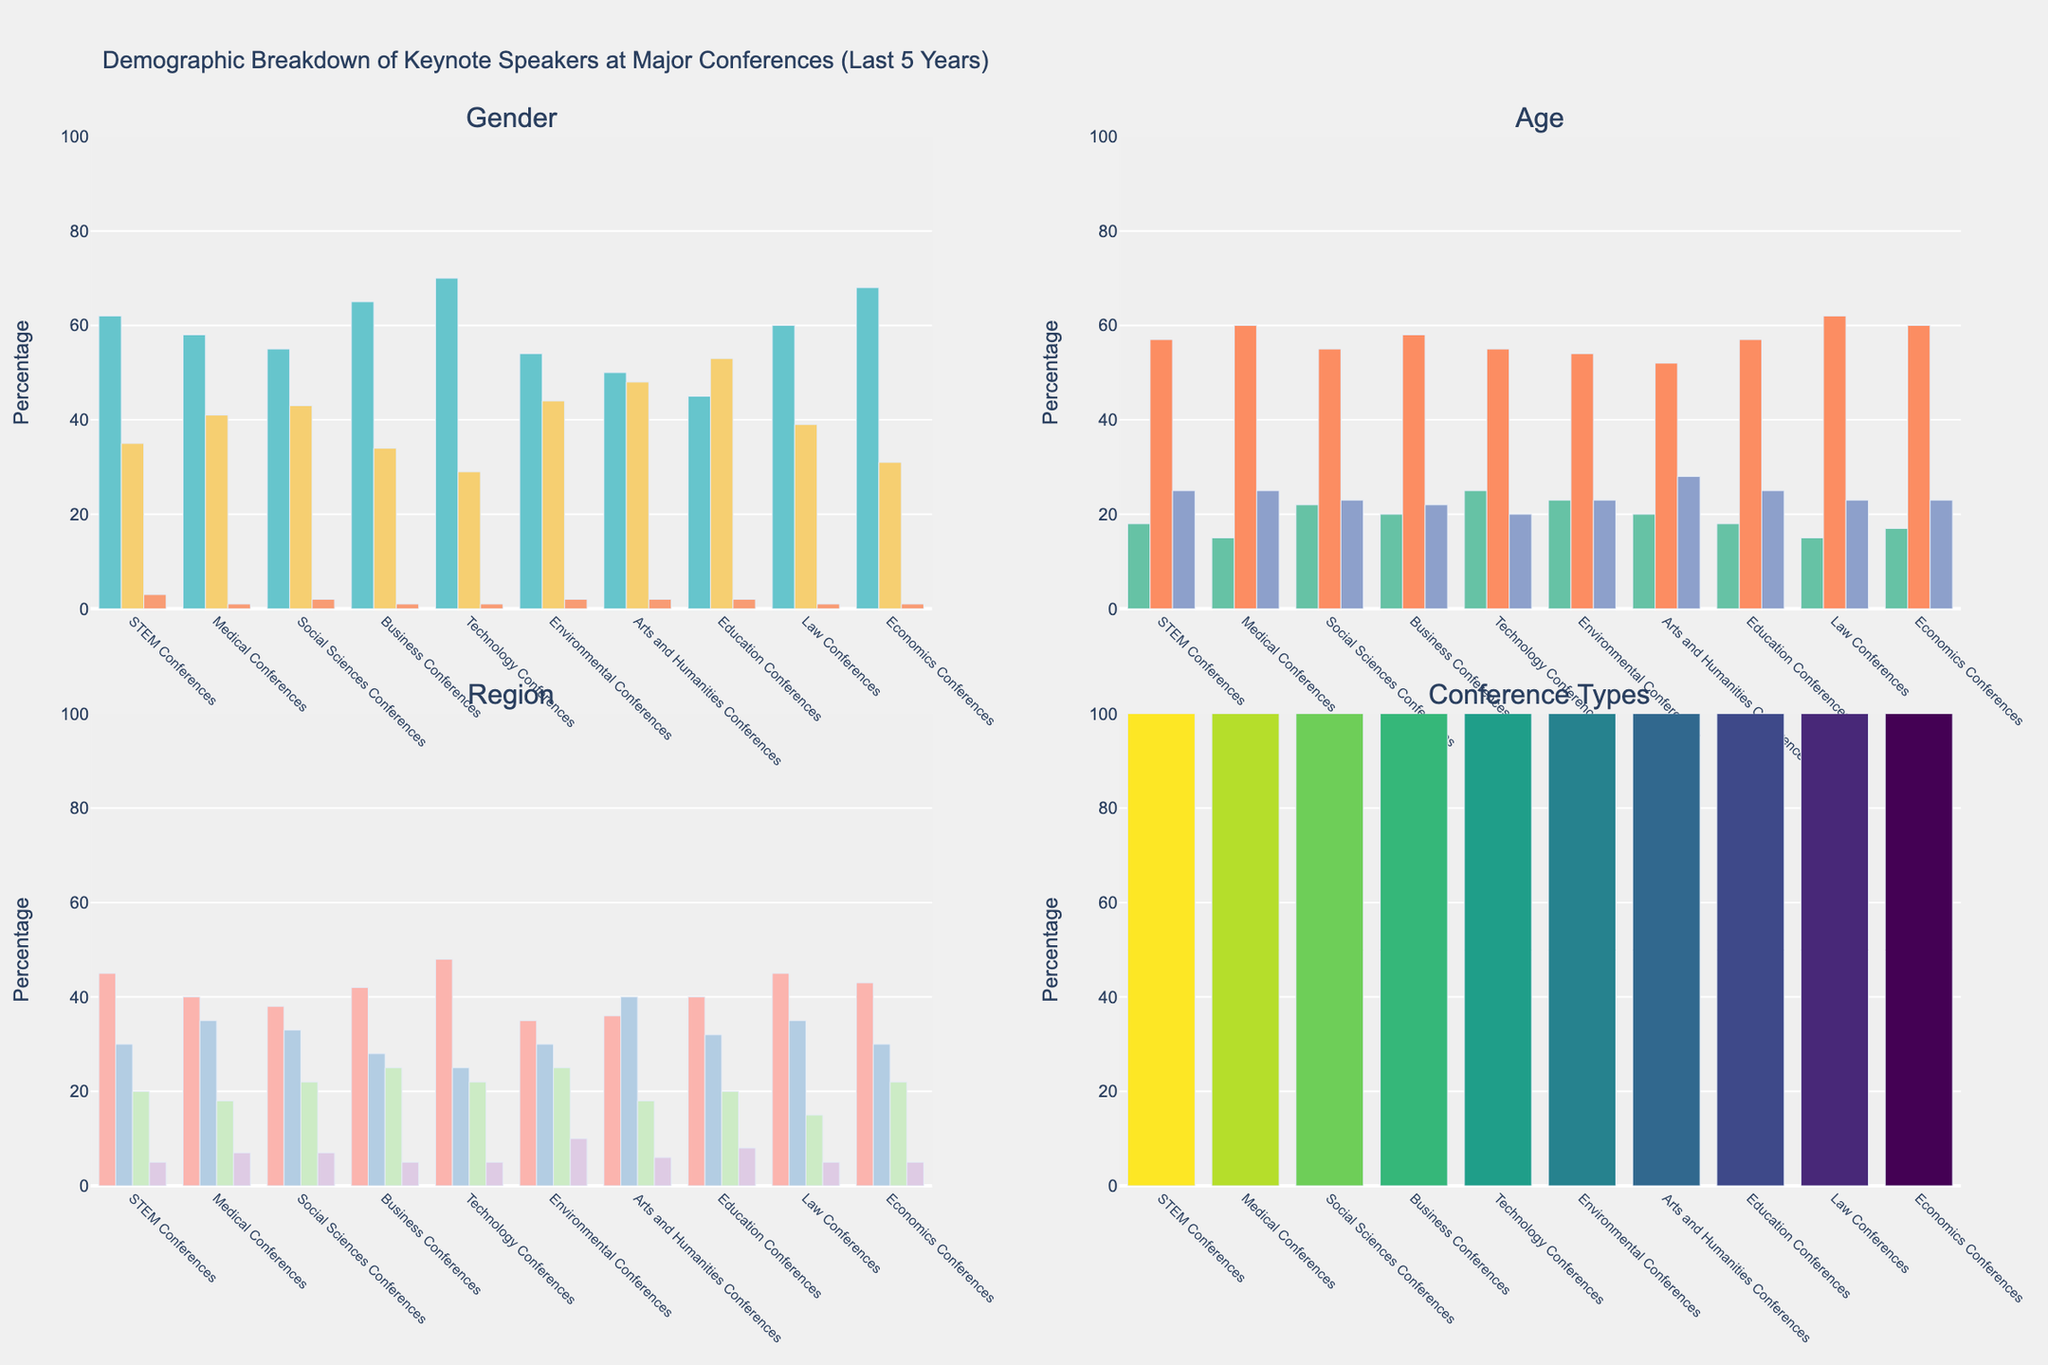What's the total number of male keynote speakers across all conference types? To find the total number of male keynote speakers, sum the numbers of males from each conference category: 62 (STEM) + 58 (Medical) + 55 (Social Sciences) + 65 (Business) + 70 (Technology) + 54 (Environmental) + 50 (Arts and Humanities) + 45 (Education) + 60 (Law) + 68 (Economics). The sum is 587.
Answer: 587 Which conference type has the highest proportion of female keynote speakers? To determine the conference type with the highest proportion of female speakers, compare the values for females across all categories: 35 (STEM), 41 (Medical), 43 (Social Sciences), 34 (Business), 29 (Technology), 44 (Environmental), 48 (Arts and Humanities), 53 (Education), 39 (Law), 31 (Economics). The highest number is 53 from Education Conferences.
Answer: Education Conferences Out of the regions, which one is the least represented in Arts and Humanities Conferences? To find the least represented region in the Arts and Humanities Conferences, compare the values for each region in that specific category: North America (36), Europe (40), Asia (18), Other (6). The smallest value is 6 from "Other".
Answer: Other How does the number of keynote speakers under 40 in Technology Conferences compare to those in STEM Conferences? To compare the number of speakers under 40, look at the values for the specific age group: 25 (Technology) and 18 (STEM). Technology Conferences have more keynote speakers under 40.
Answer: Technology Conferences have more What’s the average number of keynote speakers aged 40-60 across all conference types? To find the average number of keynote speakers aged 40-60, first sum the values from each conference category: 57 (STEM) + 60 (Medical) + 55 (Social Sciences) + 58 (Business) + 55 (Technology) + 54 (Environmental) + 52 (Arts and Humanities) + 57 (Education) + 62 (Law) + 60 (Economics). The total is 570. There are 10 conference categories, so the average is 570/10 = 57.
Answer: 57 What is the difference in the number of male and female keynote speakers for Economics Conferences? To find the difference, subtract the number of females from the number of males in Economics Conferences: 68 - 31 = 37.
Answer: 37 Which conference type has the highest number of speakers from Europe? Compare the numbers for speakers from Europe across all conference types: 30 (STEM), 35 (Medical), 33 (Social Sciences), 28 (Business), 25 (Technology), 30 (Environmental), 40 (Arts and Humanities), 32 (Education), 35 (Law), 30 (Economics). The highest number is 40 from Arts and Humanities Conferences.
Answer: Arts and Humanities Conferences 